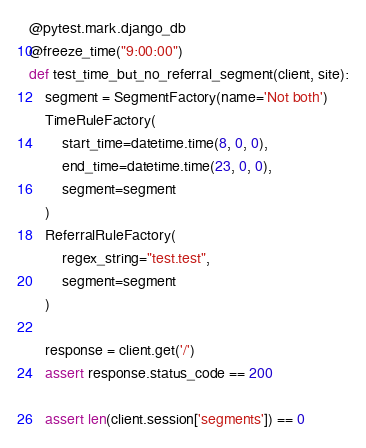Convert code to text. <code><loc_0><loc_0><loc_500><loc_500><_Python_>@pytest.mark.django_db
@freeze_time("9:00:00")
def test_time_but_no_referral_segment(client, site):
    segment = SegmentFactory(name='Not both')
    TimeRuleFactory(
        start_time=datetime.time(8, 0, 0),
        end_time=datetime.time(23, 0, 0),
        segment=segment
    )
    ReferralRuleFactory(
        regex_string="test.test",
        segment=segment
    )

    response = client.get('/')
    assert response.status_code == 200

    assert len(client.session['segments']) == 0
</code> 